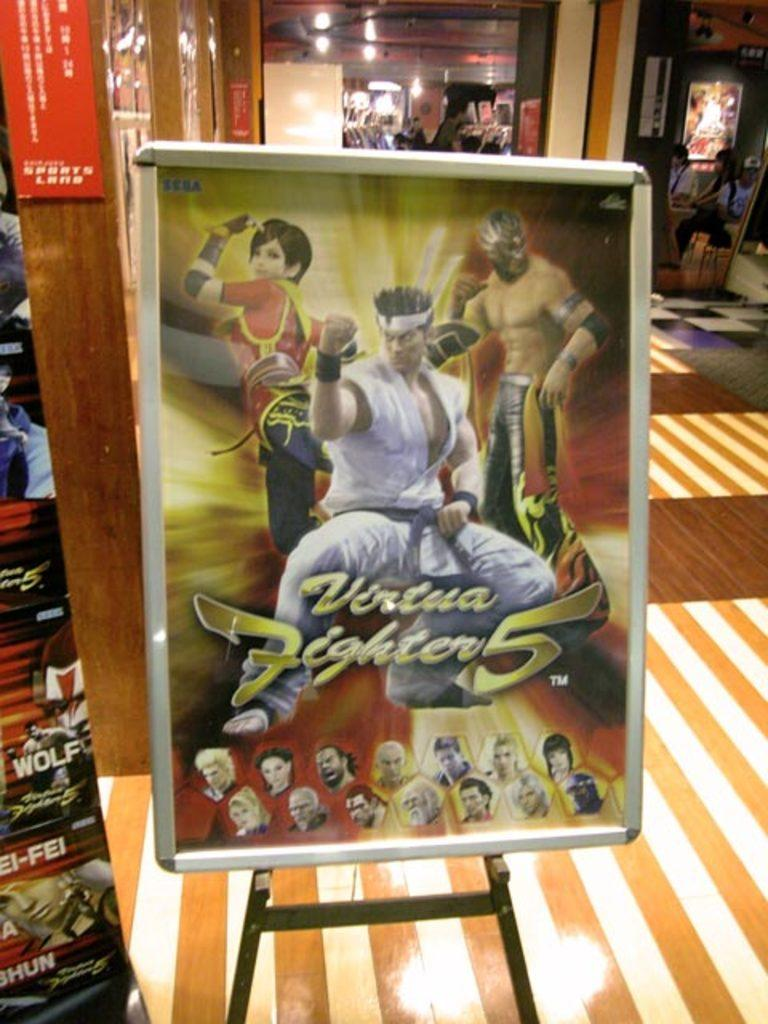<image>
Provide a brief description of the given image. A poster for Street Fighter 5 is on display in a store. 